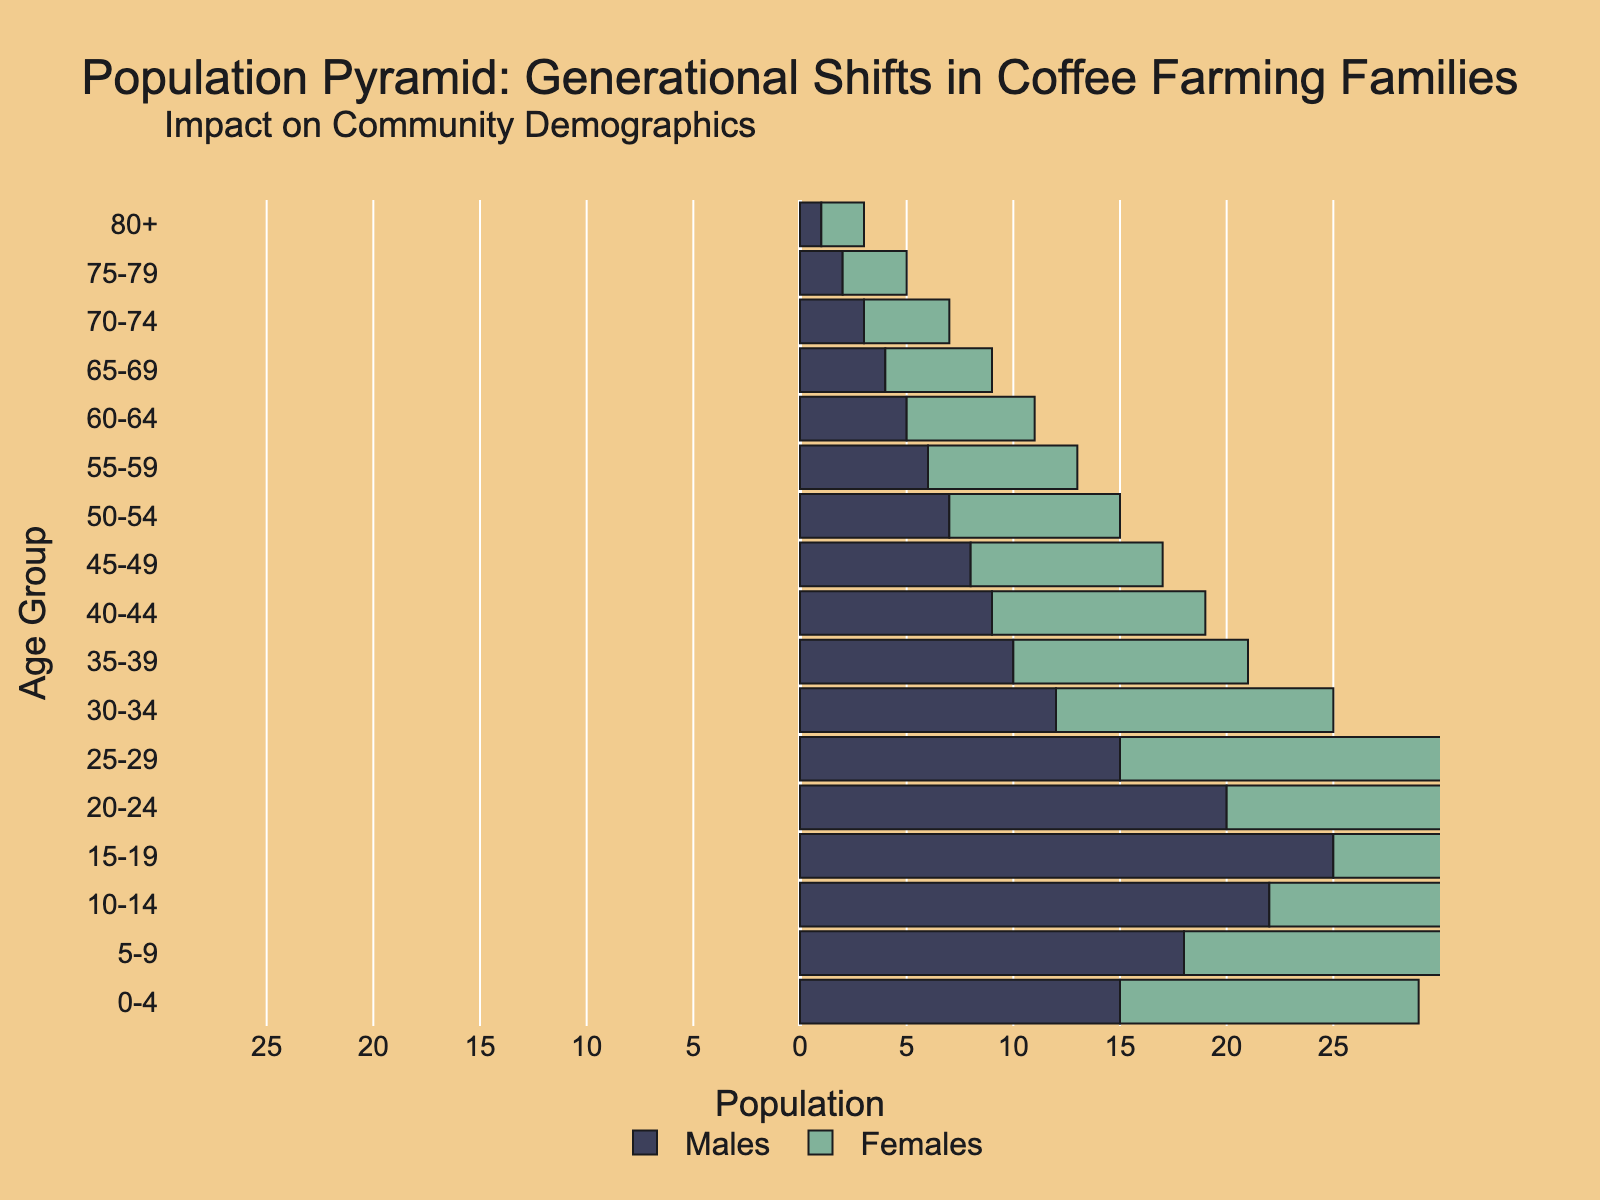Which age group has the highest population for males? Look at the age group with the largest negative bar for males since negative values represent the male population. The 15-19 age group has the highest population for males with -25 individuals.
Answer: 15-19 Which age group has the smallest difference between males and females? To find the smallest difference, compare the absolute values of the male and female populations for each age group. The 75-79 age group has -2 males and 3 females, resulting in the smallest difference of 1.
Answer: 75-79 What’s the total number of males in the 5-14 age range? Sum the number of males in the 5-9 and 10-14 age groups. For 5-9, there are -18 males, and for 10-14, there are -22 males, resulting in a total of -18 + -22 = -40 males.
Answer: 40 Which gender has more individuals in the 20-29 age range? Sum the male and female populations for the 20-24 and 25-29 age groups, then compare. For males: -20 + -15 = -35. For females: 19 + 16 = 35. Both genders have the same number in the 20-29 age range.
Answer: Equal What percentage of the total population is in the 0-4 age group for males? To calculate the percentage, divide the number of males in the 0-4 age group by the total male population and multiply by 100. Total males are the sum of the absolute values across all age groups (-15 + -18 + -22 + -25 + -20 + -15 + -12 + -10 + -9 + -8 + -7 + -6 + -5 + -4 + -3 + -2 + -1 = -172). The percentage is (-15 / -172) * 100 ≈ 8.72%.
Answer: 8.72% At which age group do females begin to outnumber males? Examine the bars from the youngest age group upward until you find the age group where the female bar is longer than the male bar. This occurs at the 15-19 age group (24 females vs. -25 males).
Answer: 15-19 Are the age groups 60+ years more populated with males or females? Sum the male and female populations in the age groups from 60 to 80+ years and compare. For males: -5 + -4 + -3 + -2 + -1 = -15. For females: 6 + 5 + 4 + 3 + 2 = 20. Females have a higher population.
Answer: Females What is the gender ratio in the 45-49 age group? Divide the number of females by the number of males in the 45-49 age group. There are 9 females and -8 males. The ratio is 9 / 8 = 1.125.
Answer: 1.125 How does the population in the 15-24 age range for males compare to the 30-39 age range for females? Sum the male population in the 15-19 and 20-24 age groups and compare it to the sum of the female population in the 30-34 and 35-39 age groups. For males: -25 + -20 = -45. For females: 13 + 11 = 24. Males in the 15-24 age range outnumber females in the 30-39 age range.
Answer: Males What does the population pyramid suggest about future trends in the coffee farming community? Analyze the shape and distribution of different age groups to infer potential future trends. The pyramid shows a higher population in younger age groups, indicating a potential for a growing or stable workforce, but the numbers start to taper off in older age groups, suggesting challenges with experienced labor and potential changes in demographics as the younger generation might pursue different opportunities.
Answer: Growing younger workforce 